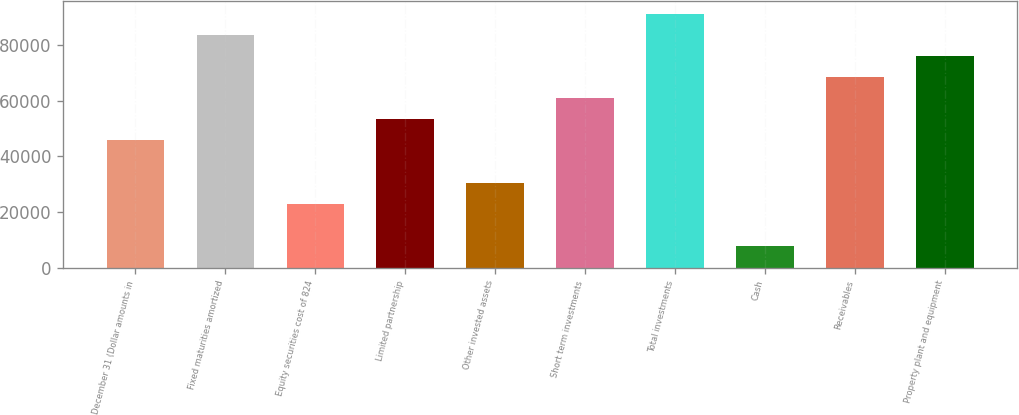Convert chart. <chart><loc_0><loc_0><loc_500><loc_500><bar_chart><fcel>December 31 (Dollar amounts in<fcel>Fixed maturities amortized<fcel>Equity securities cost of 824<fcel>Limited partnership<fcel>Other invested assets<fcel>Short term investments<fcel>Total investments<fcel>Cash<fcel>Receivables<fcel>Property plant and equipment<nl><fcel>45757.8<fcel>83596.8<fcel>23054.4<fcel>53325.6<fcel>30622.2<fcel>60893.4<fcel>91164.6<fcel>7918.8<fcel>68461.2<fcel>76029<nl></chart> 